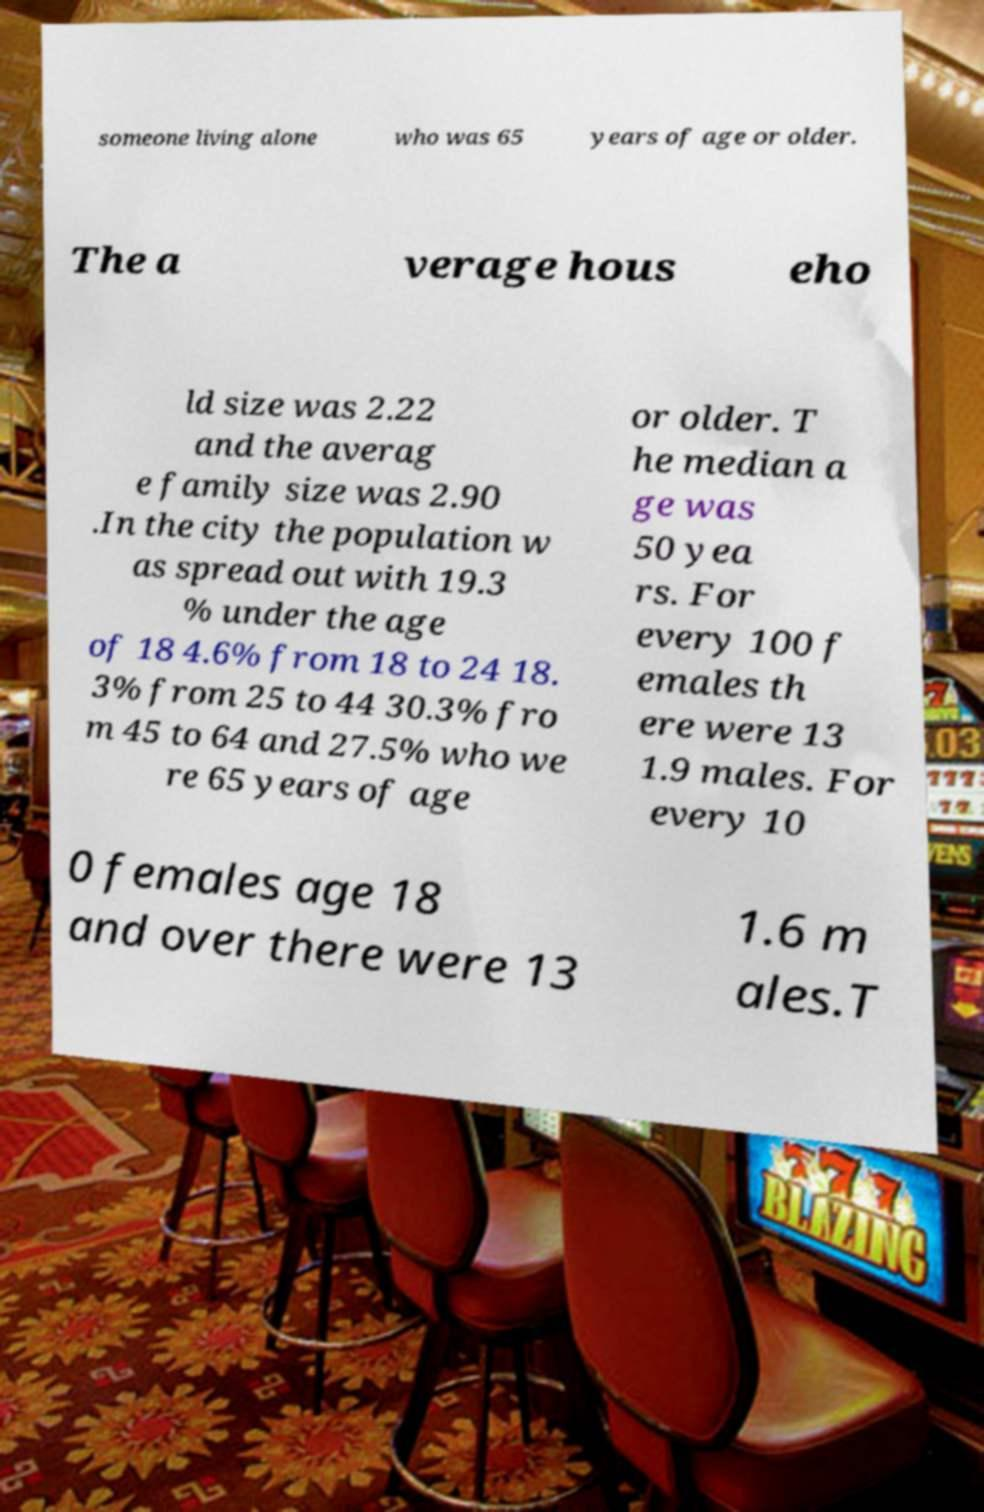What messages or text are displayed in this image? I need them in a readable, typed format. someone living alone who was 65 years of age or older. The a verage hous eho ld size was 2.22 and the averag e family size was 2.90 .In the city the population w as spread out with 19.3 % under the age of 18 4.6% from 18 to 24 18. 3% from 25 to 44 30.3% fro m 45 to 64 and 27.5% who we re 65 years of age or older. T he median a ge was 50 yea rs. For every 100 f emales th ere were 13 1.9 males. For every 10 0 females age 18 and over there were 13 1.6 m ales.T 